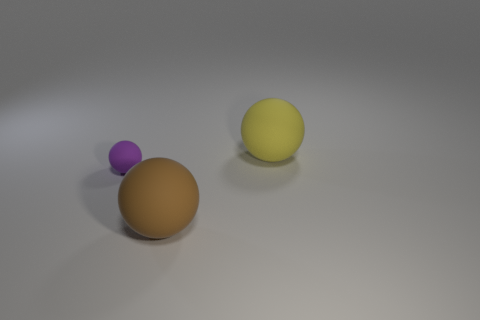Is there anything else that is the same size as the purple rubber sphere?
Offer a very short reply. No. Is the number of large brown objects that are to the left of the tiny matte sphere the same as the number of tiny gray matte cylinders?
Make the answer very short. Yes. What shape is the matte object that is on the left side of the yellow rubber thing and behind the brown matte ball?
Offer a very short reply. Sphere. Is the brown ball the same size as the yellow matte object?
Your answer should be very brief. Yes. Are there any large brown balls that have the same material as the small purple thing?
Your answer should be compact. Yes. How many objects are to the right of the tiny matte object and on the left side of the brown matte thing?
Keep it short and to the point. 0. What is the big object that is in front of the big yellow object made of?
Provide a short and direct response. Rubber. What size is the yellow object that is made of the same material as the small purple sphere?
Offer a terse response. Large. How many objects are either yellow objects or large brown rubber balls?
Your answer should be compact. 2. What is the color of the big object that is to the right of the brown rubber thing?
Make the answer very short. Yellow. 